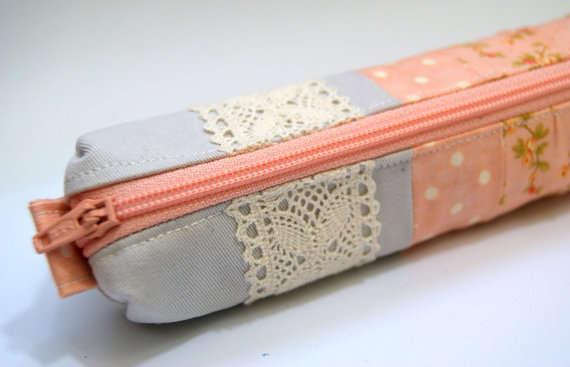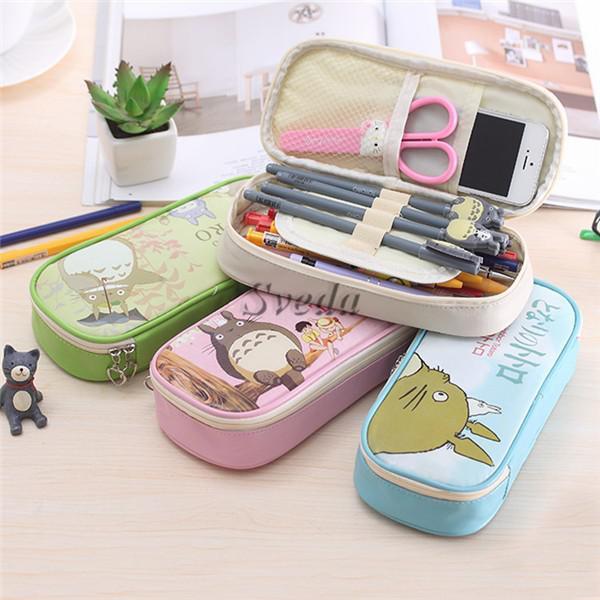The first image is the image on the left, the second image is the image on the right. Considering the images on both sides, is "There is exactly one open pencil case in the image on the right." valid? Answer yes or no. Yes. The first image is the image on the left, the second image is the image on the right. Analyze the images presented: Is the assertion "One image features soft-sided tube-shaped pencil cases with a zipper on top." valid? Answer yes or no. Yes. 